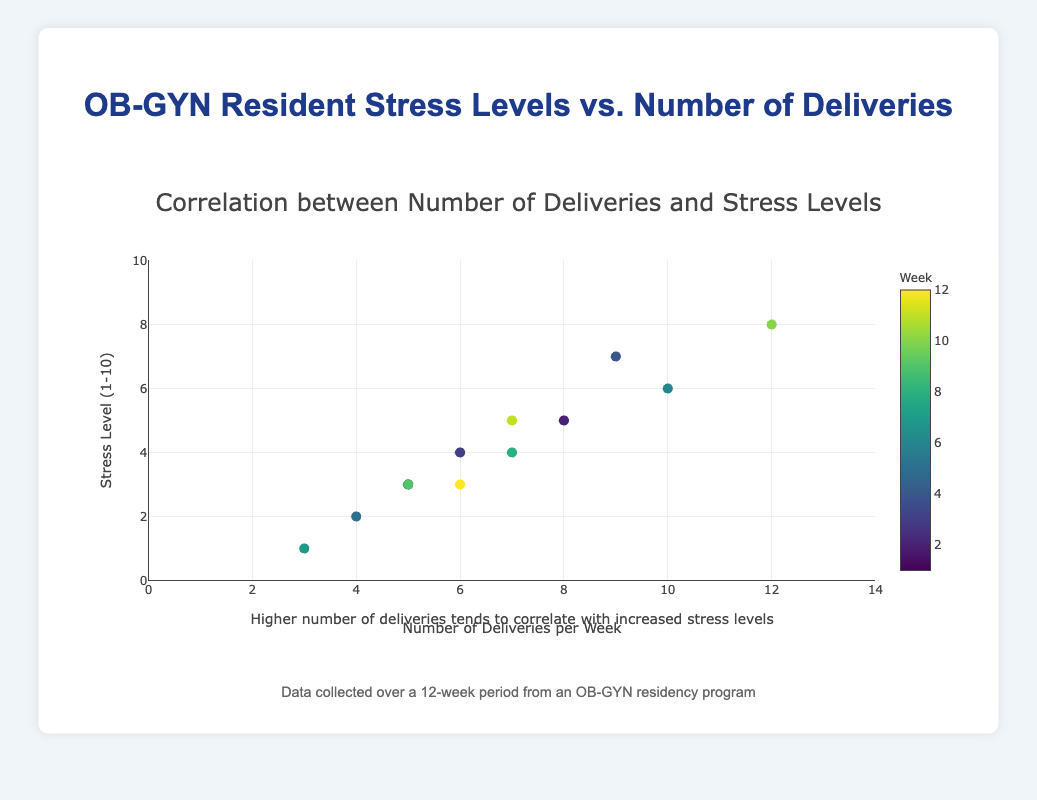How many weeks of data are represented in the plot? The title and descriptions mention that the data is collected over a 12-week period, and each data point on the scatter plot corresponds to one week. Counting the data points on the scatter plot should confirm there are 12 data points.
Answer: 12 What is the lowest stress level recorded in the data? The scatter plot shows various stress levels, and the lowest point on the y-axis is 1, which corresponds to Week 7 with 3 deliveries.
Answer: 1 Which week had the highest number of deliveries? By inspecting the scatter plot for the data point with the highest x-axis value, the highest number of deliveries per week is 12, which corresponds to Week 10.
Answer: Week 10 Is there a general trend between the number of deliveries and stress levels? The trend line added to the scatter plot indicates a positive correlation between the number of deliveries and stress levels, suggesting that higher numbers of deliveries are associated with higher stress levels.
Answer: Positive correlation What was the average stress level in weeks with exactly 7 deliveries? From the data points, Week 8 and Week 11 both have 7 deliveries. The stress levels for these weeks are 4 and 5, respectively. The average stress level is (4+5)/2 = 4.5.
Answer: 4.5 Which data point represents a week with 10 deliveries and a stress level of 6? Inspecting the scatter plot, Week 6 corresponds to 10 deliveries and a stress level of 6.
Answer: Week 6 What does the color of the markers represent on the plot? According to the description, the color of the markers represents the week of data collection, with a color scale from light to dark indicating the progression of weeks.
Answer: Week What is the difference in stress levels between the week with the highest and the week with the lowest number of deliveries? The highest number of deliveries is 12 in Week 10 with a stress level of 8. The lowest number of deliveries is 3 in Week 7 with a stress level of 1. The difference in stress levels is 8 - 1 = 7.
Answer: 7 Which week shows the closest average stress level to the overall trend line? Inspecting the scatter plot and the trend line, Week 7 and Week 1 align closely with the trend line, both having stress levels close to the overall trend.
Answer: Week 7 and Week 1 Does any week have the same number of deliveries and stress levels? By checking the scatter plot, no single data point shows the same value for both x and y coordinates; the number of deliveries and stress levels are not equal in any week.
Answer: No 